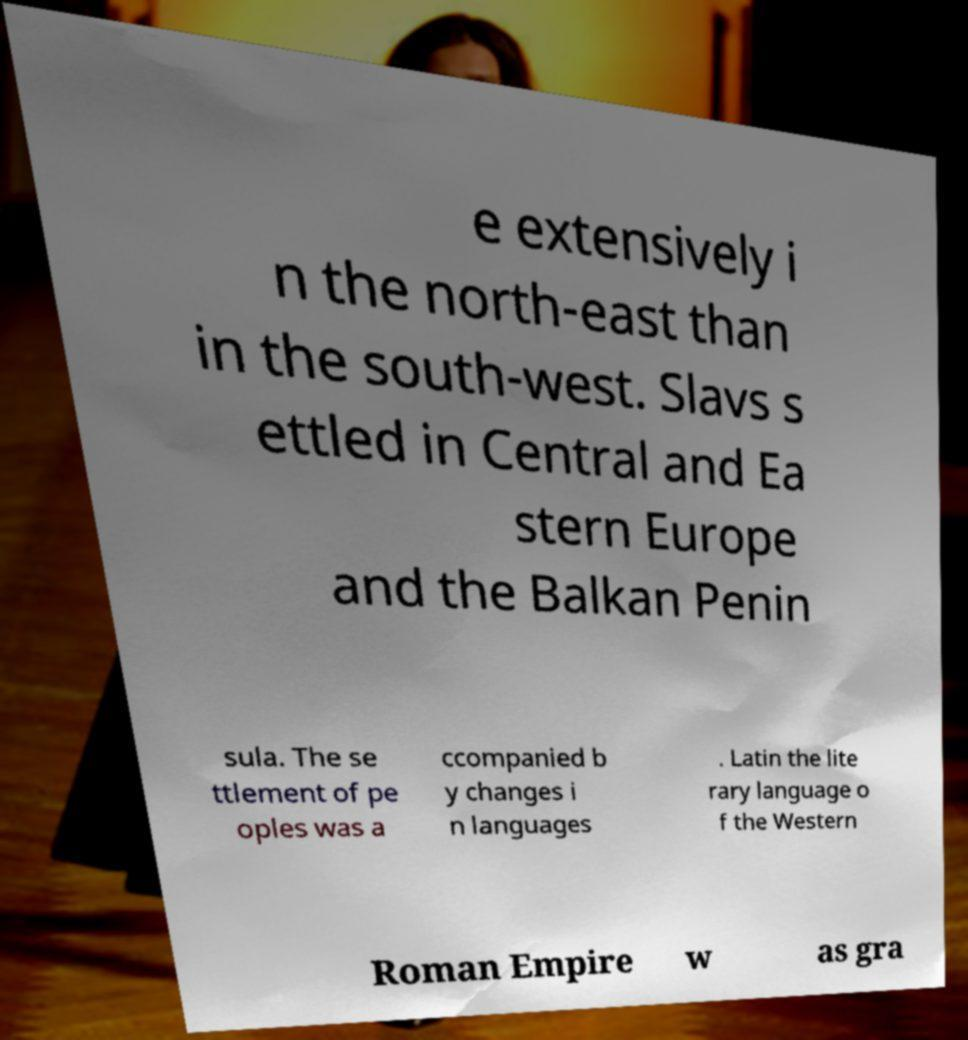Could you extract and type out the text from this image? e extensively i n the north-east than in the south-west. Slavs s ettled in Central and Ea stern Europe and the Balkan Penin sula. The se ttlement of pe oples was a ccompanied b y changes i n languages . Latin the lite rary language o f the Western Roman Empire w as gra 